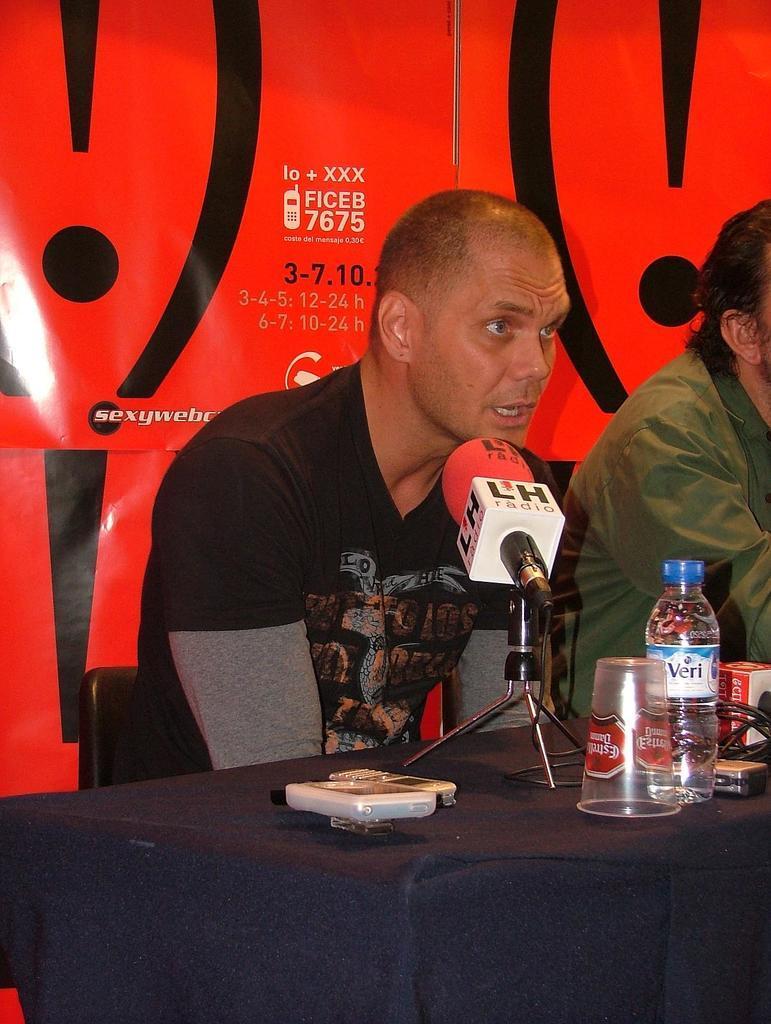In one or two sentences, can you explain what this image depicts? In this image I can see two men are sitting on chairs. On this table I can see a glass, a bottle, phones and a mic. In the background I can see a banner. I can see he is wearing black t-shirt. 